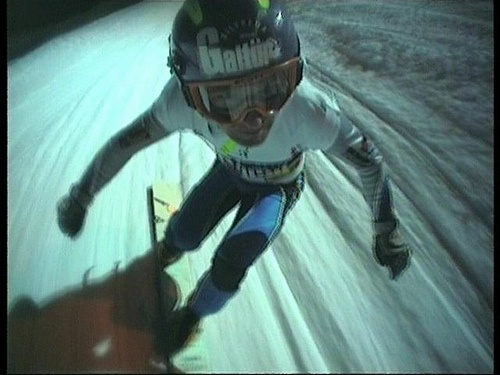Describe the objects in this image and their specific colors. I can see people in black and teal tones and snowboard in black, aquamarine, and lightgreen tones in this image. 